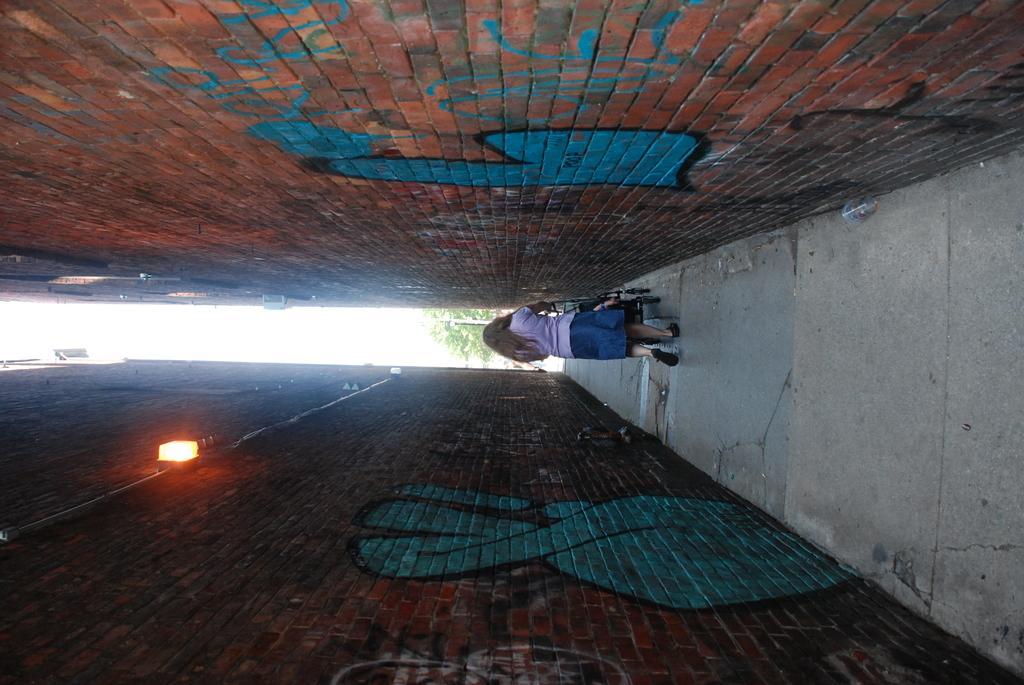Could you give a brief overview of what you see in this image? There is a woman walking on the ground and pushing a trolley with her hands. To the either side of her there are big walls and on the left side there is a light on the wall. In the background we can see trees,pole and sky. 